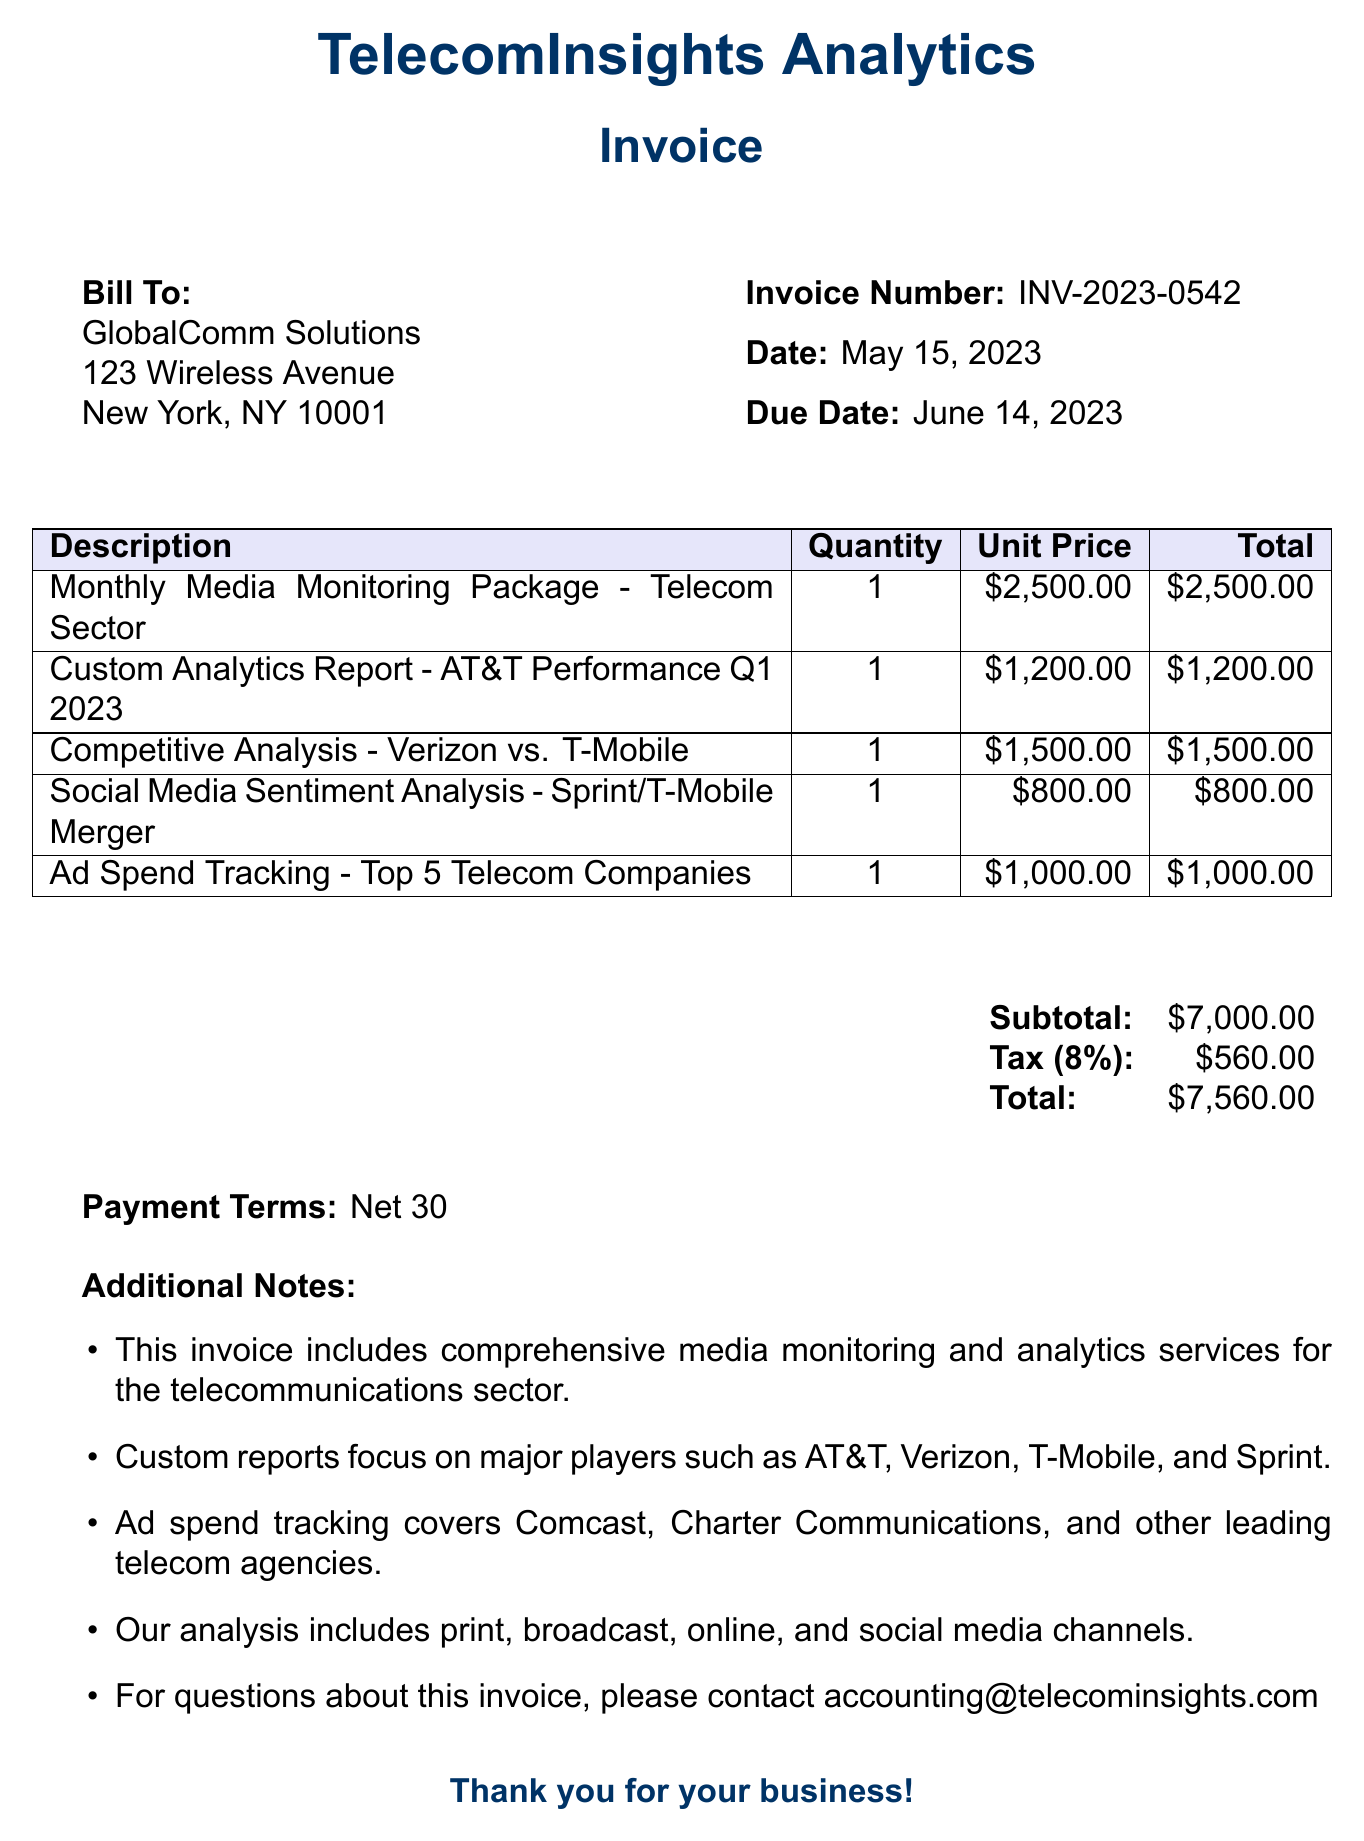What is the invoice number? The invoice number is specified in the document under "Invoice Number," which is INV-2023-0542.
Answer: INV-2023-0542 What is the date of the invoice? The date of the invoice is noted under "Date," which is May 15, 2023.
Answer: May 15, 2023 What is the total amount due? The total amount due is found under "Total," which is $7,560.00.
Answer: $7,560.00 Which service has the highest unit price? The service with the highest unit price can be identified in the list of services, which is the "Monthly Media Monitoring Package - Telecom Sector" at $2,500.00.
Answer: Monthly Media Monitoring Package - Telecom Sector What is the tax rate applied? The tax rate is mentioned under "Tax," which is 8%.
Answer: 8% What additional service focuses on AT&T's performance? The additional service that focuses on AT&T's performance is the "Custom Analytics Report - AT&T Performance Q1 2023."
Answer: Custom Analytics Report - AT&T Performance Q1 2023 What is the payment term specified? The payment term is specified as "Net 30" in the document.
Answer: Net 30 How many services are listed in the invoice? The total number of services can be counted in the provided list, which includes five services.
Answer: 5 Which telecom company is mentioned in the competitive analysis? The telecom companies mentioned in the competitive analysis are Verizon and T-Mobile.
Answer: Verizon and T-Mobile 